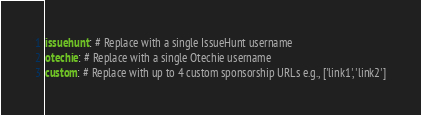<code> <loc_0><loc_0><loc_500><loc_500><_YAML_>issuehunt: # Replace with a single IssueHunt username
otechie: # Replace with a single Otechie username
custom: # Replace with up to 4 custom sponsorship URLs e.g., ['link1', 'link2']
</code> 